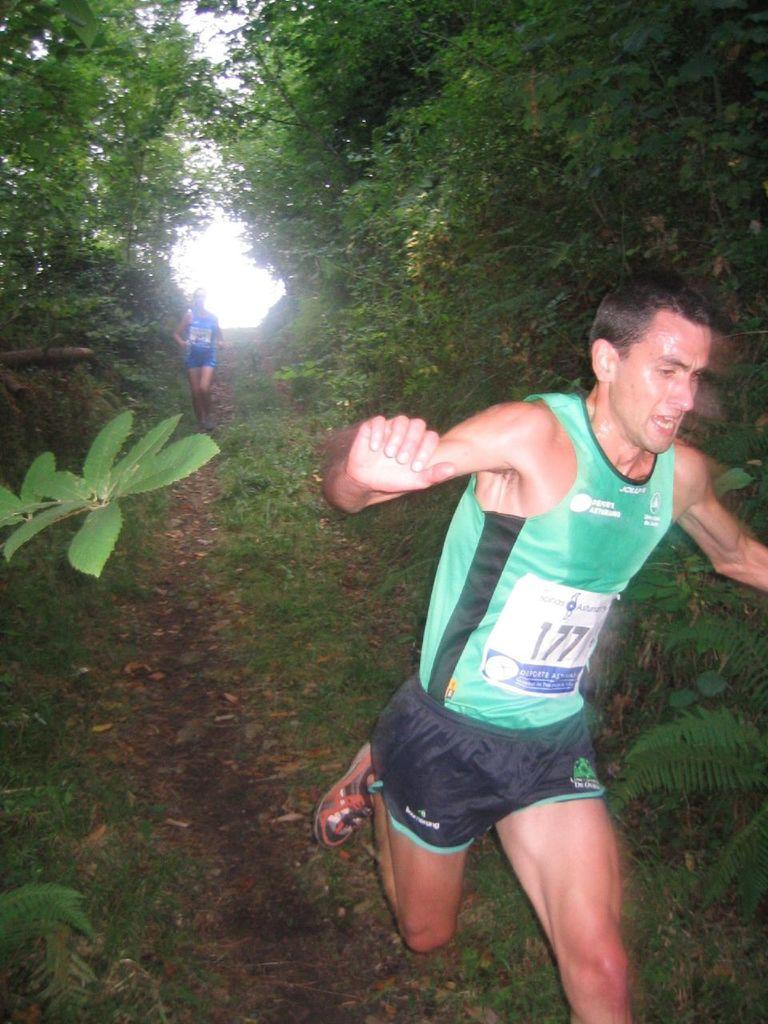What are the people in the image doing? The people in the image are running. What type of surface are they running on? The ground is covered with grass. What can be seen in the background of the image? There are trees in the image. What type of drink is being offered to the trees in the image? There are no drinks or people offering drinks to the trees in the image. 